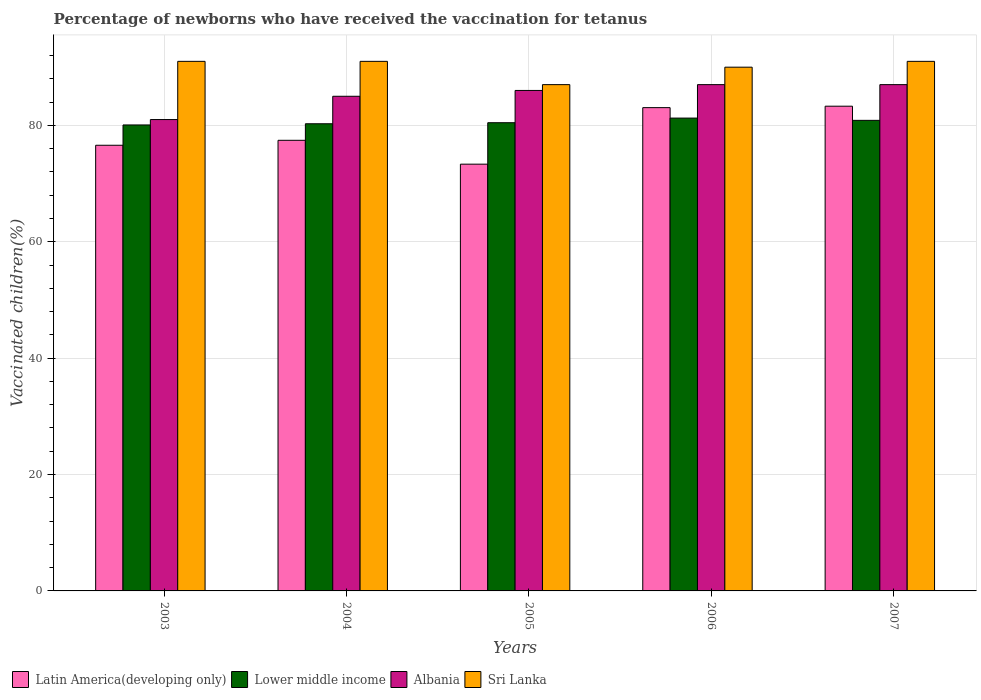How many different coloured bars are there?
Make the answer very short. 4. How many groups of bars are there?
Your answer should be very brief. 5. Are the number of bars per tick equal to the number of legend labels?
Make the answer very short. Yes. How many bars are there on the 2nd tick from the right?
Provide a succinct answer. 4. What is the percentage of vaccinated children in Latin America(developing only) in 2007?
Provide a succinct answer. 83.29. Across all years, what is the maximum percentage of vaccinated children in Lower middle income?
Offer a terse response. 81.25. Across all years, what is the minimum percentage of vaccinated children in Sri Lanka?
Your answer should be very brief. 87. What is the total percentage of vaccinated children in Latin America(developing only) in the graph?
Make the answer very short. 393.69. What is the difference between the percentage of vaccinated children in Lower middle income in 2003 and the percentage of vaccinated children in Sri Lanka in 2004?
Provide a short and direct response. -10.93. What is the average percentage of vaccinated children in Lower middle income per year?
Make the answer very short. 80.58. In how many years, is the percentage of vaccinated children in Lower middle income greater than 72 %?
Keep it short and to the point. 5. What is the ratio of the percentage of vaccinated children in Latin America(developing only) in 2005 to that in 2007?
Provide a short and direct response. 0.88. What is the difference between the highest and the second highest percentage of vaccinated children in Lower middle income?
Offer a very short reply. 0.39. What is the difference between the highest and the lowest percentage of vaccinated children in Sri Lanka?
Ensure brevity in your answer.  4. Is the sum of the percentage of vaccinated children in Latin America(developing only) in 2004 and 2007 greater than the maximum percentage of vaccinated children in Sri Lanka across all years?
Keep it short and to the point. Yes. What does the 4th bar from the left in 2007 represents?
Keep it short and to the point. Sri Lanka. What does the 2nd bar from the right in 2006 represents?
Your answer should be very brief. Albania. Is it the case that in every year, the sum of the percentage of vaccinated children in Latin America(developing only) and percentage of vaccinated children in Lower middle income is greater than the percentage of vaccinated children in Albania?
Make the answer very short. Yes. How many bars are there?
Your response must be concise. 20. Are all the bars in the graph horizontal?
Keep it short and to the point. No. What is the difference between two consecutive major ticks on the Y-axis?
Offer a terse response. 20. Are the values on the major ticks of Y-axis written in scientific E-notation?
Keep it short and to the point. No. Does the graph contain any zero values?
Offer a terse response. No. How are the legend labels stacked?
Provide a short and direct response. Horizontal. What is the title of the graph?
Your answer should be compact. Percentage of newborns who have received the vaccination for tetanus. Does "Zimbabwe" appear as one of the legend labels in the graph?
Provide a short and direct response. No. What is the label or title of the X-axis?
Offer a very short reply. Years. What is the label or title of the Y-axis?
Your answer should be very brief. Vaccinated children(%). What is the Vaccinated children(%) of Latin America(developing only) in 2003?
Keep it short and to the point. 76.58. What is the Vaccinated children(%) of Lower middle income in 2003?
Your response must be concise. 80.07. What is the Vaccinated children(%) in Albania in 2003?
Your answer should be very brief. 81. What is the Vaccinated children(%) in Sri Lanka in 2003?
Provide a short and direct response. 91. What is the Vaccinated children(%) of Latin America(developing only) in 2004?
Provide a short and direct response. 77.43. What is the Vaccinated children(%) in Lower middle income in 2004?
Give a very brief answer. 80.28. What is the Vaccinated children(%) of Albania in 2004?
Offer a terse response. 85. What is the Vaccinated children(%) of Sri Lanka in 2004?
Give a very brief answer. 91. What is the Vaccinated children(%) in Latin America(developing only) in 2005?
Provide a succinct answer. 73.33. What is the Vaccinated children(%) of Lower middle income in 2005?
Your answer should be very brief. 80.46. What is the Vaccinated children(%) in Albania in 2005?
Your answer should be compact. 86. What is the Vaccinated children(%) in Latin America(developing only) in 2006?
Your answer should be compact. 83.05. What is the Vaccinated children(%) of Lower middle income in 2006?
Your answer should be very brief. 81.25. What is the Vaccinated children(%) in Albania in 2006?
Ensure brevity in your answer.  87. What is the Vaccinated children(%) in Latin America(developing only) in 2007?
Give a very brief answer. 83.29. What is the Vaccinated children(%) of Lower middle income in 2007?
Offer a very short reply. 80.86. What is the Vaccinated children(%) in Sri Lanka in 2007?
Offer a terse response. 91. Across all years, what is the maximum Vaccinated children(%) of Latin America(developing only)?
Provide a short and direct response. 83.29. Across all years, what is the maximum Vaccinated children(%) of Lower middle income?
Your answer should be compact. 81.25. Across all years, what is the maximum Vaccinated children(%) of Sri Lanka?
Ensure brevity in your answer.  91. Across all years, what is the minimum Vaccinated children(%) of Latin America(developing only)?
Provide a succinct answer. 73.33. Across all years, what is the minimum Vaccinated children(%) of Lower middle income?
Provide a succinct answer. 80.07. Across all years, what is the minimum Vaccinated children(%) of Albania?
Offer a terse response. 81. Across all years, what is the minimum Vaccinated children(%) of Sri Lanka?
Provide a short and direct response. 87. What is the total Vaccinated children(%) of Latin America(developing only) in the graph?
Keep it short and to the point. 393.69. What is the total Vaccinated children(%) of Lower middle income in the graph?
Make the answer very short. 402.92. What is the total Vaccinated children(%) of Albania in the graph?
Your answer should be compact. 426. What is the total Vaccinated children(%) of Sri Lanka in the graph?
Keep it short and to the point. 450. What is the difference between the Vaccinated children(%) in Latin America(developing only) in 2003 and that in 2004?
Offer a very short reply. -0.85. What is the difference between the Vaccinated children(%) in Lower middle income in 2003 and that in 2004?
Offer a very short reply. -0.21. What is the difference between the Vaccinated children(%) in Albania in 2003 and that in 2004?
Your answer should be compact. -4. What is the difference between the Vaccinated children(%) in Sri Lanka in 2003 and that in 2004?
Provide a succinct answer. 0. What is the difference between the Vaccinated children(%) of Latin America(developing only) in 2003 and that in 2005?
Keep it short and to the point. 3.25. What is the difference between the Vaccinated children(%) in Lower middle income in 2003 and that in 2005?
Ensure brevity in your answer.  -0.38. What is the difference between the Vaccinated children(%) of Albania in 2003 and that in 2005?
Make the answer very short. -5. What is the difference between the Vaccinated children(%) of Latin America(developing only) in 2003 and that in 2006?
Offer a terse response. -6.46. What is the difference between the Vaccinated children(%) in Lower middle income in 2003 and that in 2006?
Your answer should be compact. -1.18. What is the difference between the Vaccinated children(%) in Albania in 2003 and that in 2006?
Keep it short and to the point. -6. What is the difference between the Vaccinated children(%) in Latin America(developing only) in 2003 and that in 2007?
Make the answer very short. -6.71. What is the difference between the Vaccinated children(%) of Lower middle income in 2003 and that in 2007?
Offer a terse response. -0.79. What is the difference between the Vaccinated children(%) in Latin America(developing only) in 2004 and that in 2005?
Ensure brevity in your answer.  4.1. What is the difference between the Vaccinated children(%) of Lower middle income in 2004 and that in 2005?
Give a very brief answer. -0.18. What is the difference between the Vaccinated children(%) in Sri Lanka in 2004 and that in 2005?
Your response must be concise. 4. What is the difference between the Vaccinated children(%) in Latin America(developing only) in 2004 and that in 2006?
Keep it short and to the point. -5.61. What is the difference between the Vaccinated children(%) in Lower middle income in 2004 and that in 2006?
Give a very brief answer. -0.97. What is the difference between the Vaccinated children(%) in Albania in 2004 and that in 2006?
Provide a short and direct response. -2. What is the difference between the Vaccinated children(%) in Latin America(developing only) in 2004 and that in 2007?
Your answer should be very brief. -5.86. What is the difference between the Vaccinated children(%) in Lower middle income in 2004 and that in 2007?
Provide a short and direct response. -0.58. What is the difference between the Vaccinated children(%) in Latin America(developing only) in 2005 and that in 2006?
Provide a short and direct response. -9.71. What is the difference between the Vaccinated children(%) in Lower middle income in 2005 and that in 2006?
Offer a terse response. -0.8. What is the difference between the Vaccinated children(%) in Albania in 2005 and that in 2006?
Make the answer very short. -1. What is the difference between the Vaccinated children(%) in Latin America(developing only) in 2005 and that in 2007?
Offer a terse response. -9.96. What is the difference between the Vaccinated children(%) of Lower middle income in 2005 and that in 2007?
Make the answer very short. -0.41. What is the difference between the Vaccinated children(%) of Albania in 2005 and that in 2007?
Offer a terse response. -1. What is the difference between the Vaccinated children(%) in Latin America(developing only) in 2006 and that in 2007?
Provide a succinct answer. -0.25. What is the difference between the Vaccinated children(%) in Lower middle income in 2006 and that in 2007?
Offer a terse response. 0.39. What is the difference between the Vaccinated children(%) of Albania in 2006 and that in 2007?
Give a very brief answer. 0. What is the difference between the Vaccinated children(%) in Latin America(developing only) in 2003 and the Vaccinated children(%) in Lower middle income in 2004?
Provide a succinct answer. -3.69. What is the difference between the Vaccinated children(%) in Latin America(developing only) in 2003 and the Vaccinated children(%) in Albania in 2004?
Your answer should be compact. -8.42. What is the difference between the Vaccinated children(%) of Latin America(developing only) in 2003 and the Vaccinated children(%) of Sri Lanka in 2004?
Provide a succinct answer. -14.42. What is the difference between the Vaccinated children(%) in Lower middle income in 2003 and the Vaccinated children(%) in Albania in 2004?
Ensure brevity in your answer.  -4.93. What is the difference between the Vaccinated children(%) of Lower middle income in 2003 and the Vaccinated children(%) of Sri Lanka in 2004?
Your response must be concise. -10.93. What is the difference between the Vaccinated children(%) in Latin America(developing only) in 2003 and the Vaccinated children(%) in Lower middle income in 2005?
Your answer should be compact. -3.87. What is the difference between the Vaccinated children(%) in Latin America(developing only) in 2003 and the Vaccinated children(%) in Albania in 2005?
Make the answer very short. -9.42. What is the difference between the Vaccinated children(%) in Latin America(developing only) in 2003 and the Vaccinated children(%) in Sri Lanka in 2005?
Offer a very short reply. -10.42. What is the difference between the Vaccinated children(%) of Lower middle income in 2003 and the Vaccinated children(%) of Albania in 2005?
Your response must be concise. -5.93. What is the difference between the Vaccinated children(%) of Lower middle income in 2003 and the Vaccinated children(%) of Sri Lanka in 2005?
Make the answer very short. -6.93. What is the difference between the Vaccinated children(%) in Latin America(developing only) in 2003 and the Vaccinated children(%) in Lower middle income in 2006?
Offer a terse response. -4.67. What is the difference between the Vaccinated children(%) in Latin America(developing only) in 2003 and the Vaccinated children(%) in Albania in 2006?
Ensure brevity in your answer.  -10.42. What is the difference between the Vaccinated children(%) of Latin America(developing only) in 2003 and the Vaccinated children(%) of Sri Lanka in 2006?
Provide a succinct answer. -13.42. What is the difference between the Vaccinated children(%) in Lower middle income in 2003 and the Vaccinated children(%) in Albania in 2006?
Your answer should be compact. -6.93. What is the difference between the Vaccinated children(%) in Lower middle income in 2003 and the Vaccinated children(%) in Sri Lanka in 2006?
Offer a terse response. -9.93. What is the difference between the Vaccinated children(%) in Latin America(developing only) in 2003 and the Vaccinated children(%) in Lower middle income in 2007?
Offer a very short reply. -4.28. What is the difference between the Vaccinated children(%) of Latin America(developing only) in 2003 and the Vaccinated children(%) of Albania in 2007?
Your response must be concise. -10.42. What is the difference between the Vaccinated children(%) in Latin America(developing only) in 2003 and the Vaccinated children(%) in Sri Lanka in 2007?
Make the answer very short. -14.42. What is the difference between the Vaccinated children(%) in Lower middle income in 2003 and the Vaccinated children(%) in Albania in 2007?
Your answer should be very brief. -6.93. What is the difference between the Vaccinated children(%) in Lower middle income in 2003 and the Vaccinated children(%) in Sri Lanka in 2007?
Provide a succinct answer. -10.93. What is the difference between the Vaccinated children(%) of Albania in 2003 and the Vaccinated children(%) of Sri Lanka in 2007?
Provide a succinct answer. -10. What is the difference between the Vaccinated children(%) in Latin America(developing only) in 2004 and the Vaccinated children(%) in Lower middle income in 2005?
Provide a succinct answer. -3.02. What is the difference between the Vaccinated children(%) of Latin America(developing only) in 2004 and the Vaccinated children(%) of Albania in 2005?
Offer a very short reply. -8.57. What is the difference between the Vaccinated children(%) of Latin America(developing only) in 2004 and the Vaccinated children(%) of Sri Lanka in 2005?
Make the answer very short. -9.57. What is the difference between the Vaccinated children(%) of Lower middle income in 2004 and the Vaccinated children(%) of Albania in 2005?
Offer a terse response. -5.72. What is the difference between the Vaccinated children(%) of Lower middle income in 2004 and the Vaccinated children(%) of Sri Lanka in 2005?
Your answer should be compact. -6.72. What is the difference between the Vaccinated children(%) in Latin America(developing only) in 2004 and the Vaccinated children(%) in Lower middle income in 2006?
Provide a short and direct response. -3.82. What is the difference between the Vaccinated children(%) in Latin America(developing only) in 2004 and the Vaccinated children(%) in Albania in 2006?
Ensure brevity in your answer.  -9.57. What is the difference between the Vaccinated children(%) in Latin America(developing only) in 2004 and the Vaccinated children(%) in Sri Lanka in 2006?
Make the answer very short. -12.57. What is the difference between the Vaccinated children(%) of Lower middle income in 2004 and the Vaccinated children(%) of Albania in 2006?
Make the answer very short. -6.72. What is the difference between the Vaccinated children(%) in Lower middle income in 2004 and the Vaccinated children(%) in Sri Lanka in 2006?
Provide a succinct answer. -9.72. What is the difference between the Vaccinated children(%) of Latin America(developing only) in 2004 and the Vaccinated children(%) of Lower middle income in 2007?
Offer a very short reply. -3.43. What is the difference between the Vaccinated children(%) in Latin America(developing only) in 2004 and the Vaccinated children(%) in Albania in 2007?
Your answer should be compact. -9.57. What is the difference between the Vaccinated children(%) in Latin America(developing only) in 2004 and the Vaccinated children(%) in Sri Lanka in 2007?
Your answer should be very brief. -13.57. What is the difference between the Vaccinated children(%) of Lower middle income in 2004 and the Vaccinated children(%) of Albania in 2007?
Your answer should be compact. -6.72. What is the difference between the Vaccinated children(%) in Lower middle income in 2004 and the Vaccinated children(%) in Sri Lanka in 2007?
Your answer should be compact. -10.72. What is the difference between the Vaccinated children(%) of Latin America(developing only) in 2005 and the Vaccinated children(%) of Lower middle income in 2006?
Your answer should be very brief. -7.92. What is the difference between the Vaccinated children(%) of Latin America(developing only) in 2005 and the Vaccinated children(%) of Albania in 2006?
Provide a succinct answer. -13.67. What is the difference between the Vaccinated children(%) of Latin America(developing only) in 2005 and the Vaccinated children(%) of Sri Lanka in 2006?
Ensure brevity in your answer.  -16.67. What is the difference between the Vaccinated children(%) of Lower middle income in 2005 and the Vaccinated children(%) of Albania in 2006?
Provide a short and direct response. -6.54. What is the difference between the Vaccinated children(%) in Lower middle income in 2005 and the Vaccinated children(%) in Sri Lanka in 2006?
Offer a very short reply. -9.54. What is the difference between the Vaccinated children(%) in Albania in 2005 and the Vaccinated children(%) in Sri Lanka in 2006?
Offer a terse response. -4. What is the difference between the Vaccinated children(%) of Latin America(developing only) in 2005 and the Vaccinated children(%) of Lower middle income in 2007?
Your response must be concise. -7.53. What is the difference between the Vaccinated children(%) of Latin America(developing only) in 2005 and the Vaccinated children(%) of Albania in 2007?
Your answer should be very brief. -13.67. What is the difference between the Vaccinated children(%) of Latin America(developing only) in 2005 and the Vaccinated children(%) of Sri Lanka in 2007?
Your answer should be compact. -17.67. What is the difference between the Vaccinated children(%) in Lower middle income in 2005 and the Vaccinated children(%) in Albania in 2007?
Ensure brevity in your answer.  -6.54. What is the difference between the Vaccinated children(%) of Lower middle income in 2005 and the Vaccinated children(%) of Sri Lanka in 2007?
Ensure brevity in your answer.  -10.54. What is the difference between the Vaccinated children(%) in Latin America(developing only) in 2006 and the Vaccinated children(%) in Lower middle income in 2007?
Provide a short and direct response. 2.19. What is the difference between the Vaccinated children(%) of Latin America(developing only) in 2006 and the Vaccinated children(%) of Albania in 2007?
Make the answer very short. -3.95. What is the difference between the Vaccinated children(%) of Latin America(developing only) in 2006 and the Vaccinated children(%) of Sri Lanka in 2007?
Give a very brief answer. -7.95. What is the difference between the Vaccinated children(%) of Lower middle income in 2006 and the Vaccinated children(%) of Albania in 2007?
Your answer should be compact. -5.75. What is the difference between the Vaccinated children(%) of Lower middle income in 2006 and the Vaccinated children(%) of Sri Lanka in 2007?
Offer a very short reply. -9.75. What is the difference between the Vaccinated children(%) of Albania in 2006 and the Vaccinated children(%) of Sri Lanka in 2007?
Your answer should be very brief. -4. What is the average Vaccinated children(%) of Latin America(developing only) per year?
Offer a very short reply. 78.74. What is the average Vaccinated children(%) of Lower middle income per year?
Give a very brief answer. 80.58. What is the average Vaccinated children(%) of Albania per year?
Your response must be concise. 85.2. In the year 2003, what is the difference between the Vaccinated children(%) of Latin America(developing only) and Vaccinated children(%) of Lower middle income?
Make the answer very short. -3.49. In the year 2003, what is the difference between the Vaccinated children(%) of Latin America(developing only) and Vaccinated children(%) of Albania?
Offer a terse response. -4.42. In the year 2003, what is the difference between the Vaccinated children(%) of Latin America(developing only) and Vaccinated children(%) of Sri Lanka?
Ensure brevity in your answer.  -14.42. In the year 2003, what is the difference between the Vaccinated children(%) of Lower middle income and Vaccinated children(%) of Albania?
Provide a short and direct response. -0.93. In the year 2003, what is the difference between the Vaccinated children(%) in Lower middle income and Vaccinated children(%) in Sri Lanka?
Your answer should be very brief. -10.93. In the year 2004, what is the difference between the Vaccinated children(%) of Latin America(developing only) and Vaccinated children(%) of Lower middle income?
Make the answer very short. -2.84. In the year 2004, what is the difference between the Vaccinated children(%) in Latin America(developing only) and Vaccinated children(%) in Albania?
Your response must be concise. -7.57. In the year 2004, what is the difference between the Vaccinated children(%) in Latin America(developing only) and Vaccinated children(%) in Sri Lanka?
Your response must be concise. -13.57. In the year 2004, what is the difference between the Vaccinated children(%) in Lower middle income and Vaccinated children(%) in Albania?
Offer a very short reply. -4.72. In the year 2004, what is the difference between the Vaccinated children(%) in Lower middle income and Vaccinated children(%) in Sri Lanka?
Offer a terse response. -10.72. In the year 2005, what is the difference between the Vaccinated children(%) of Latin America(developing only) and Vaccinated children(%) of Lower middle income?
Your answer should be very brief. -7.12. In the year 2005, what is the difference between the Vaccinated children(%) of Latin America(developing only) and Vaccinated children(%) of Albania?
Give a very brief answer. -12.67. In the year 2005, what is the difference between the Vaccinated children(%) of Latin America(developing only) and Vaccinated children(%) of Sri Lanka?
Offer a terse response. -13.67. In the year 2005, what is the difference between the Vaccinated children(%) in Lower middle income and Vaccinated children(%) in Albania?
Keep it short and to the point. -5.54. In the year 2005, what is the difference between the Vaccinated children(%) of Lower middle income and Vaccinated children(%) of Sri Lanka?
Provide a short and direct response. -6.54. In the year 2006, what is the difference between the Vaccinated children(%) in Latin America(developing only) and Vaccinated children(%) in Lower middle income?
Offer a very short reply. 1.8. In the year 2006, what is the difference between the Vaccinated children(%) of Latin America(developing only) and Vaccinated children(%) of Albania?
Offer a terse response. -3.95. In the year 2006, what is the difference between the Vaccinated children(%) in Latin America(developing only) and Vaccinated children(%) in Sri Lanka?
Make the answer very short. -6.95. In the year 2006, what is the difference between the Vaccinated children(%) in Lower middle income and Vaccinated children(%) in Albania?
Offer a very short reply. -5.75. In the year 2006, what is the difference between the Vaccinated children(%) in Lower middle income and Vaccinated children(%) in Sri Lanka?
Keep it short and to the point. -8.75. In the year 2006, what is the difference between the Vaccinated children(%) of Albania and Vaccinated children(%) of Sri Lanka?
Your response must be concise. -3. In the year 2007, what is the difference between the Vaccinated children(%) in Latin America(developing only) and Vaccinated children(%) in Lower middle income?
Ensure brevity in your answer.  2.43. In the year 2007, what is the difference between the Vaccinated children(%) in Latin America(developing only) and Vaccinated children(%) in Albania?
Offer a terse response. -3.71. In the year 2007, what is the difference between the Vaccinated children(%) of Latin America(developing only) and Vaccinated children(%) of Sri Lanka?
Make the answer very short. -7.71. In the year 2007, what is the difference between the Vaccinated children(%) of Lower middle income and Vaccinated children(%) of Albania?
Offer a very short reply. -6.14. In the year 2007, what is the difference between the Vaccinated children(%) in Lower middle income and Vaccinated children(%) in Sri Lanka?
Offer a very short reply. -10.14. What is the ratio of the Vaccinated children(%) of Latin America(developing only) in 2003 to that in 2004?
Your response must be concise. 0.99. What is the ratio of the Vaccinated children(%) of Lower middle income in 2003 to that in 2004?
Make the answer very short. 1. What is the ratio of the Vaccinated children(%) of Albania in 2003 to that in 2004?
Provide a succinct answer. 0.95. What is the ratio of the Vaccinated children(%) in Latin America(developing only) in 2003 to that in 2005?
Your answer should be compact. 1.04. What is the ratio of the Vaccinated children(%) of Albania in 2003 to that in 2005?
Keep it short and to the point. 0.94. What is the ratio of the Vaccinated children(%) of Sri Lanka in 2003 to that in 2005?
Your answer should be compact. 1.05. What is the ratio of the Vaccinated children(%) of Latin America(developing only) in 2003 to that in 2006?
Offer a terse response. 0.92. What is the ratio of the Vaccinated children(%) of Lower middle income in 2003 to that in 2006?
Your answer should be very brief. 0.99. What is the ratio of the Vaccinated children(%) in Sri Lanka in 2003 to that in 2006?
Ensure brevity in your answer.  1.01. What is the ratio of the Vaccinated children(%) in Latin America(developing only) in 2003 to that in 2007?
Your answer should be compact. 0.92. What is the ratio of the Vaccinated children(%) of Lower middle income in 2003 to that in 2007?
Your answer should be very brief. 0.99. What is the ratio of the Vaccinated children(%) in Albania in 2003 to that in 2007?
Give a very brief answer. 0.93. What is the ratio of the Vaccinated children(%) of Latin America(developing only) in 2004 to that in 2005?
Offer a very short reply. 1.06. What is the ratio of the Vaccinated children(%) of Lower middle income in 2004 to that in 2005?
Keep it short and to the point. 1. What is the ratio of the Vaccinated children(%) in Albania in 2004 to that in 2005?
Keep it short and to the point. 0.99. What is the ratio of the Vaccinated children(%) of Sri Lanka in 2004 to that in 2005?
Make the answer very short. 1.05. What is the ratio of the Vaccinated children(%) of Latin America(developing only) in 2004 to that in 2006?
Your answer should be compact. 0.93. What is the ratio of the Vaccinated children(%) in Albania in 2004 to that in 2006?
Your answer should be very brief. 0.98. What is the ratio of the Vaccinated children(%) in Sri Lanka in 2004 to that in 2006?
Ensure brevity in your answer.  1.01. What is the ratio of the Vaccinated children(%) of Latin America(developing only) in 2004 to that in 2007?
Provide a succinct answer. 0.93. What is the ratio of the Vaccinated children(%) in Albania in 2004 to that in 2007?
Provide a short and direct response. 0.98. What is the ratio of the Vaccinated children(%) in Latin America(developing only) in 2005 to that in 2006?
Make the answer very short. 0.88. What is the ratio of the Vaccinated children(%) in Lower middle income in 2005 to that in 2006?
Your response must be concise. 0.99. What is the ratio of the Vaccinated children(%) of Sri Lanka in 2005 to that in 2006?
Provide a short and direct response. 0.97. What is the ratio of the Vaccinated children(%) of Latin America(developing only) in 2005 to that in 2007?
Keep it short and to the point. 0.88. What is the ratio of the Vaccinated children(%) in Lower middle income in 2005 to that in 2007?
Your answer should be compact. 0.99. What is the ratio of the Vaccinated children(%) in Albania in 2005 to that in 2007?
Offer a terse response. 0.99. What is the ratio of the Vaccinated children(%) in Sri Lanka in 2005 to that in 2007?
Offer a terse response. 0.96. What is the ratio of the Vaccinated children(%) in Latin America(developing only) in 2006 to that in 2007?
Your answer should be very brief. 1. What is the ratio of the Vaccinated children(%) in Lower middle income in 2006 to that in 2007?
Ensure brevity in your answer.  1. What is the ratio of the Vaccinated children(%) of Sri Lanka in 2006 to that in 2007?
Give a very brief answer. 0.99. What is the difference between the highest and the second highest Vaccinated children(%) of Latin America(developing only)?
Offer a terse response. 0.25. What is the difference between the highest and the second highest Vaccinated children(%) of Lower middle income?
Give a very brief answer. 0.39. What is the difference between the highest and the second highest Vaccinated children(%) in Sri Lanka?
Ensure brevity in your answer.  0. What is the difference between the highest and the lowest Vaccinated children(%) in Latin America(developing only)?
Your response must be concise. 9.96. What is the difference between the highest and the lowest Vaccinated children(%) in Lower middle income?
Provide a short and direct response. 1.18. 